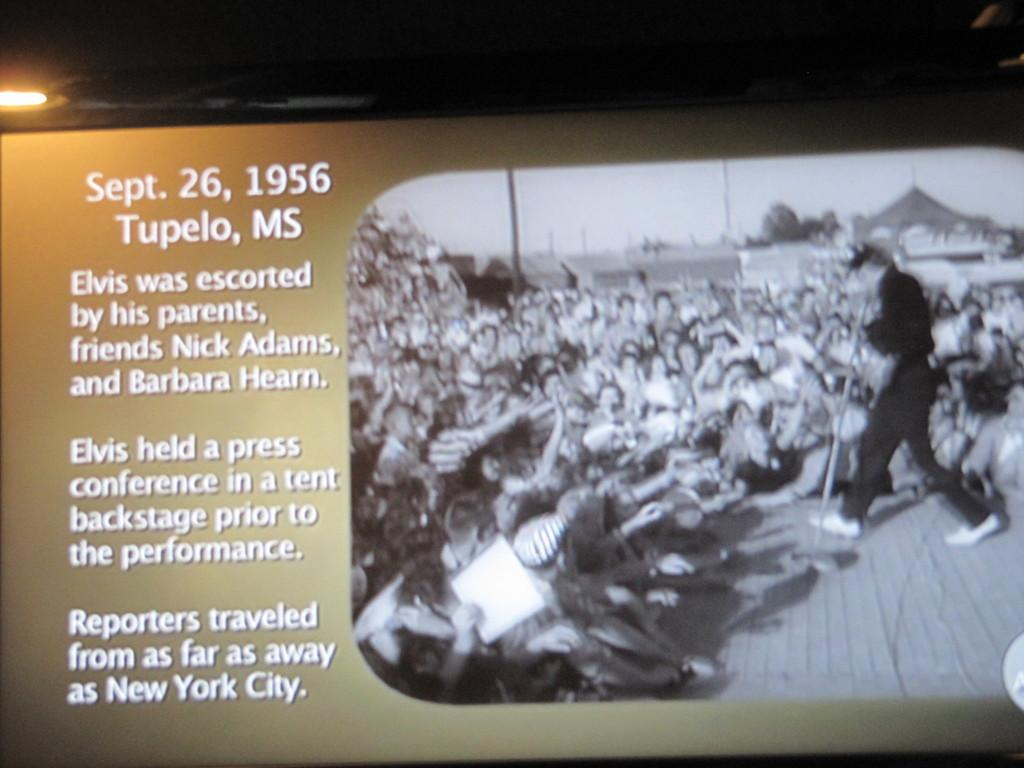What is the man in the image doing? The man is walking in the image. On which side of the image is the man located? The man is on the right side of the image. What is the man wearing? The man is wearing a black dress. What can be observed on the opposite side of the man in the image? There are many people on the left side of the image. What is the title of the book the man is holding in the image? The man is not holding a book in the image, so there is no title to provide. 